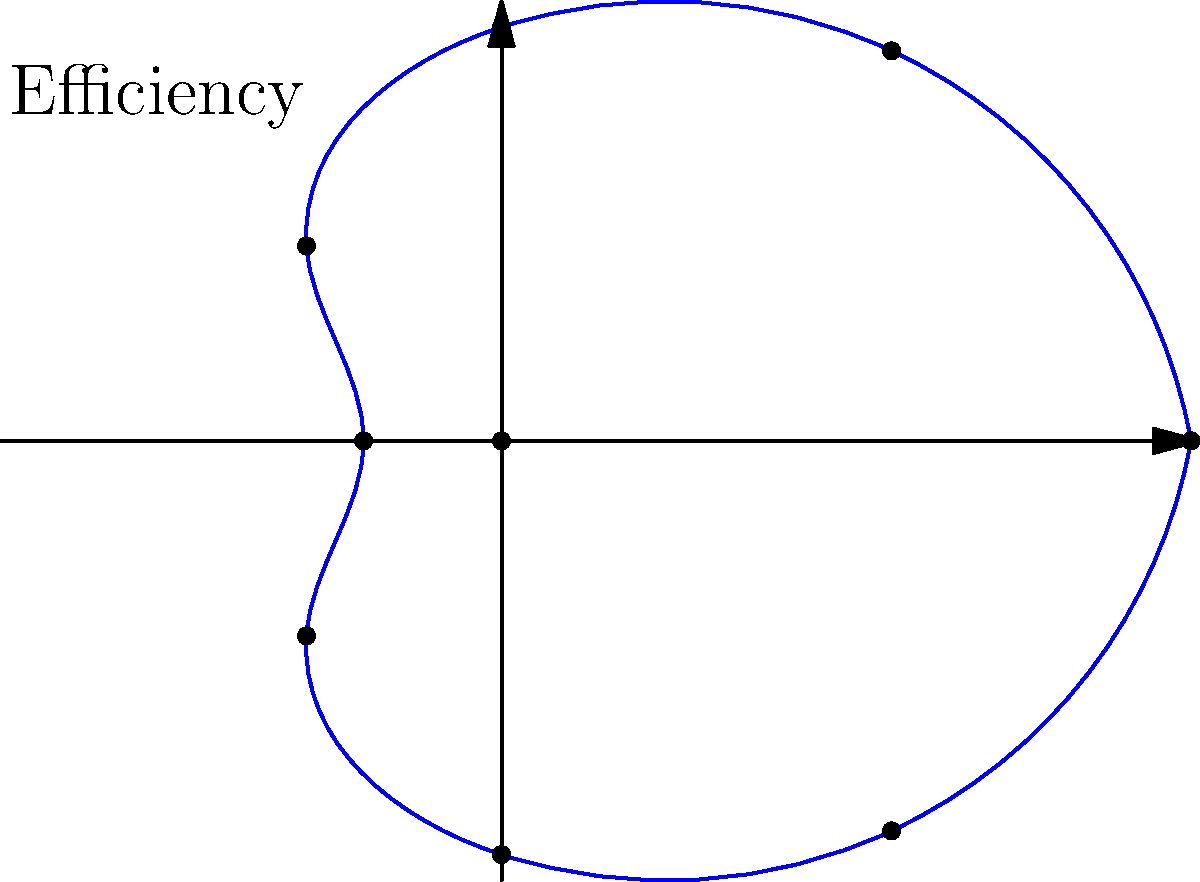At the sushi conveyor belt restaurant where you work, management has implemented a new system to track the efficiency of different stations throughout the day. The polar graph above represents the efficiency of various stations, with the distance from the center indicating higher efficiency. Which station (represented by the points on the graph) appears to be the least efficient? To determine the least efficient station, we need to identify the point closest to the center of the polar graph. Let's break it down:

1. In a polar graph, the distance from the center (origin) represents the magnitude of the measured value, in this case, efficiency.
2. The graph shows 8 points, each representing a different station in the restaurant.
3. The points farther from the center indicate higher efficiency, while those closer to the center indicate lower efficiency.
4. Looking at the graph, we can see that the points form a shape resembling a rounded square.
5. The point at the bottom of the graph, corresponding to $\theta = \pi$ (or 180 degrees), is clearly the closest to the center.
6. This point has the smallest radial distance, which means it represents the station with the lowest efficiency.

Therefore, the station represented by the point at the bottom of the graph (at $\theta = \pi$) is the least efficient.
Answer: The station at $\theta = \pi$ (bottom of the graph) 